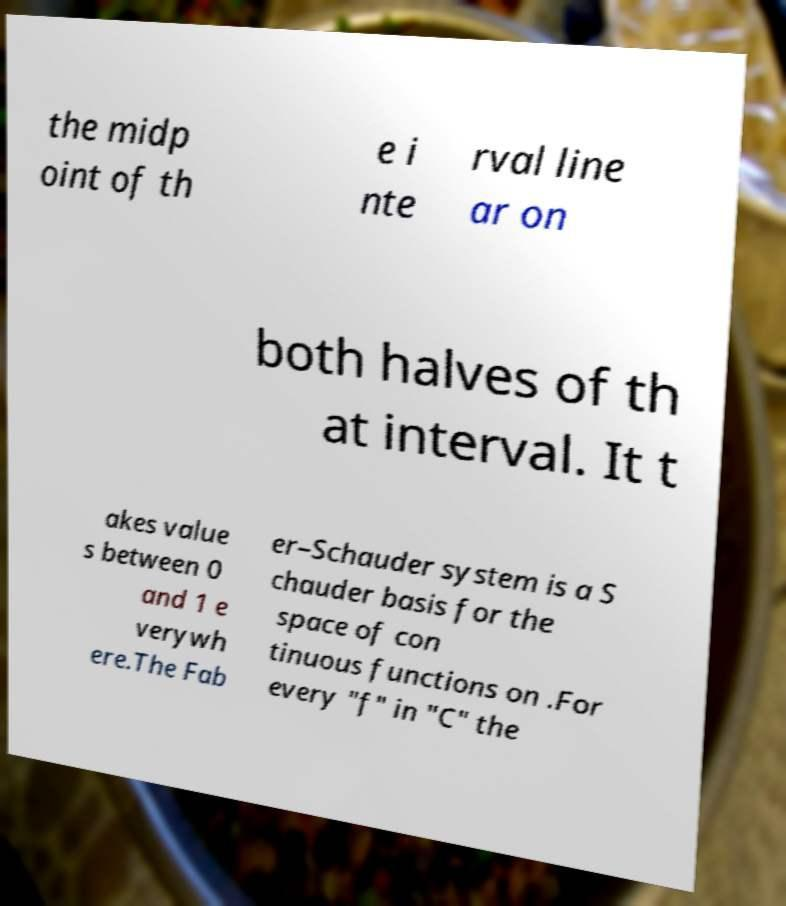What messages or text are displayed in this image? I need them in a readable, typed format. the midp oint of th e i nte rval line ar on both halves of th at interval. It t akes value s between 0 and 1 e verywh ere.The Fab er–Schauder system is a S chauder basis for the space of con tinuous functions on .For every "f" in "C" the 